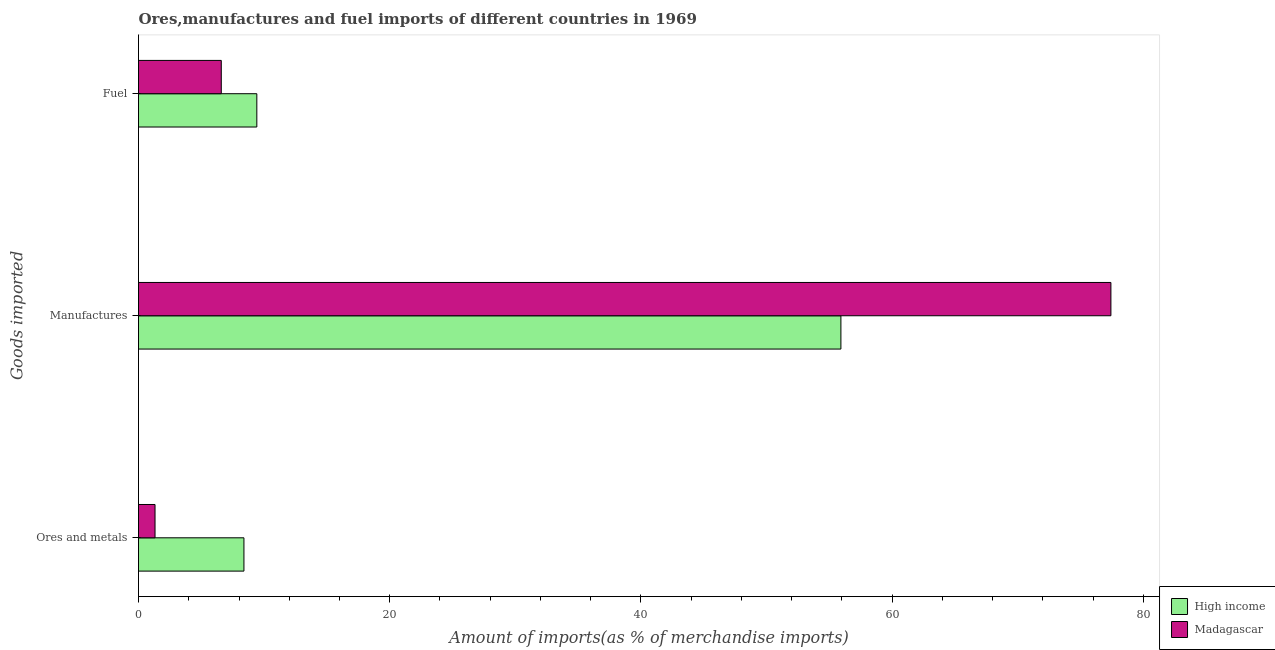How many different coloured bars are there?
Offer a very short reply. 2. Are the number of bars per tick equal to the number of legend labels?
Your answer should be very brief. Yes. How many bars are there on the 1st tick from the top?
Your answer should be compact. 2. What is the label of the 2nd group of bars from the top?
Your answer should be compact. Manufactures. What is the percentage of fuel imports in Madagascar?
Make the answer very short. 6.59. Across all countries, what is the maximum percentage of manufactures imports?
Make the answer very short. 77.41. Across all countries, what is the minimum percentage of fuel imports?
Give a very brief answer. 6.59. In which country was the percentage of fuel imports maximum?
Keep it short and to the point. High income. In which country was the percentage of fuel imports minimum?
Your answer should be very brief. Madagascar. What is the total percentage of fuel imports in the graph?
Offer a very short reply. 16.01. What is the difference between the percentage of manufactures imports in High income and that in Madagascar?
Ensure brevity in your answer.  -21.49. What is the difference between the percentage of manufactures imports in Madagascar and the percentage of fuel imports in High income?
Offer a very short reply. 67.99. What is the average percentage of fuel imports per country?
Your answer should be compact. 8. What is the difference between the percentage of ores and metals imports and percentage of manufactures imports in High income?
Your answer should be compact. -47.53. What is the ratio of the percentage of ores and metals imports in High income to that in Madagascar?
Offer a terse response. 6.38. What is the difference between the highest and the second highest percentage of manufactures imports?
Offer a very short reply. 21.49. What is the difference between the highest and the lowest percentage of fuel imports?
Give a very brief answer. 2.83. Is the sum of the percentage of fuel imports in Madagascar and High income greater than the maximum percentage of manufactures imports across all countries?
Provide a short and direct response. No. What does the 1st bar from the top in Ores and metals represents?
Give a very brief answer. Madagascar. Is it the case that in every country, the sum of the percentage of ores and metals imports and percentage of manufactures imports is greater than the percentage of fuel imports?
Your response must be concise. Yes. How many countries are there in the graph?
Give a very brief answer. 2. Are the values on the major ticks of X-axis written in scientific E-notation?
Your answer should be very brief. No. Does the graph contain grids?
Your answer should be compact. No. How many legend labels are there?
Offer a terse response. 2. How are the legend labels stacked?
Give a very brief answer. Vertical. What is the title of the graph?
Keep it short and to the point. Ores,manufactures and fuel imports of different countries in 1969. Does "Papua New Guinea" appear as one of the legend labels in the graph?
Provide a short and direct response. No. What is the label or title of the X-axis?
Make the answer very short. Amount of imports(as % of merchandise imports). What is the label or title of the Y-axis?
Ensure brevity in your answer.  Goods imported. What is the Amount of imports(as % of merchandise imports) of High income in Ores and metals?
Give a very brief answer. 8.39. What is the Amount of imports(as % of merchandise imports) in Madagascar in Ores and metals?
Ensure brevity in your answer.  1.31. What is the Amount of imports(as % of merchandise imports) of High income in Manufactures?
Offer a very short reply. 55.92. What is the Amount of imports(as % of merchandise imports) of Madagascar in Manufactures?
Ensure brevity in your answer.  77.41. What is the Amount of imports(as % of merchandise imports) of High income in Fuel?
Your response must be concise. 9.42. What is the Amount of imports(as % of merchandise imports) in Madagascar in Fuel?
Provide a short and direct response. 6.59. Across all Goods imported, what is the maximum Amount of imports(as % of merchandise imports) of High income?
Make the answer very short. 55.92. Across all Goods imported, what is the maximum Amount of imports(as % of merchandise imports) in Madagascar?
Offer a terse response. 77.41. Across all Goods imported, what is the minimum Amount of imports(as % of merchandise imports) of High income?
Offer a very short reply. 8.39. Across all Goods imported, what is the minimum Amount of imports(as % of merchandise imports) in Madagascar?
Offer a terse response. 1.31. What is the total Amount of imports(as % of merchandise imports) in High income in the graph?
Your answer should be very brief. 73.73. What is the total Amount of imports(as % of merchandise imports) of Madagascar in the graph?
Offer a very short reply. 85.32. What is the difference between the Amount of imports(as % of merchandise imports) in High income in Ores and metals and that in Manufactures?
Your answer should be very brief. -47.53. What is the difference between the Amount of imports(as % of merchandise imports) in Madagascar in Ores and metals and that in Manufactures?
Keep it short and to the point. -76.1. What is the difference between the Amount of imports(as % of merchandise imports) of High income in Ores and metals and that in Fuel?
Your answer should be very brief. -1.03. What is the difference between the Amount of imports(as % of merchandise imports) of Madagascar in Ores and metals and that in Fuel?
Ensure brevity in your answer.  -5.28. What is the difference between the Amount of imports(as % of merchandise imports) in High income in Manufactures and that in Fuel?
Your answer should be compact. 46.5. What is the difference between the Amount of imports(as % of merchandise imports) in Madagascar in Manufactures and that in Fuel?
Give a very brief answer. 70.82. What is the difference between the Amount of imports(as % of merchandise imports) in High income in Ores and metals and the Amount of imports(as % of merchandise imports) in Madagascar in Manufactures?
Provide a short and direct response. -69.02. What is the difference between the Amount of imports(as % of merchandise imports) in High income in Ores and metals and the Amount of imports(as % of merchandise imports) in Madagascar in Fuel?
Your answer should be very brief. 1.8. What is the difference between the Amount of imports(as % of merchandise imports) in High income in Manufactures and the Amount of imports(as % of merchandise imports) in Madagascar in Fuel?
Provide a succinct answer. 49.33. What is the average Amount of imports(as % of merchandise imports) in High income per Goods imported?
Offer a terse response. 24.58. What is the average Amount of imports(as % of merchandise imports) in Madagascar per Goods imported?
Offer a terse response. 28.44. What is the difference between the Amount of imports(as % of merchandise imports) of High income and Amount of imports(as % of merchandise imports) of Madagascar in Ores and metals?
Ensure brevity in your answer.  7.08. What is the difference between the Amount of imports(as % of merchandise imports) in High income and Amount of imports(as % of merchandise imports) in Madagascar in Manufactures?
Make the answer very short. -21.49. What is the difference between the Amount of imports(as % of merchandise imports) in High income and Amount of imports(as % of merchandise imports) in Madagascar in Fuel?
Your answer should be compact. 2.83. What is the ratio of the Amount of imports(as % of merchandise imports) in High income in Ores and metals to that in Manufactures?
Make the answer very short. 0.15. What is the ratio of the Amount of imports(as % of merchandise imports) in Madagascar in Ores and metals to that in Manufactures?
Your answer should be very brief. 0.02. What is the ratio of the Amount of imports(as % of merchandise imports) of High income in Ores and metals to that in Fuel?
Your response must be concise. 0.89. What is the ratio of the Amount of imports(as % of merchandise imports) in Madagascar in Ores and metals to that in Fuel?
Give a very brief answer. 0.2. What is the ratio of the Amount of imports(as % of merchandise imports) in High income in Manufactures to that in Fuel?
Ensure brevity in your answer.  5.94. What is the ratio of the Amount of imports(as % of merchandise imports) of Madagascar in Manufactures to that in Fuel?
Your answer should be very brief. 11.75. What is the difference between the highest and the second highest Amount of imports(as % of merchandise imports) in High income?
Ensure brevity in your answer.  46.5. What is the difference between the highest and the second highest Amount of imports(as % of merchandise imports) of Madagascar?
Ensure brevity in your answer.  70.82. What is the difference between the highest and the lowest Amount of imports(as % of merchandise imports) of High income?
Offer a terse response. 47.53. What is the difference between the highest and the lowest Amount of imports(as % of merchandise imports) of Madagascar?
Offer a very short reply. 76.1. 